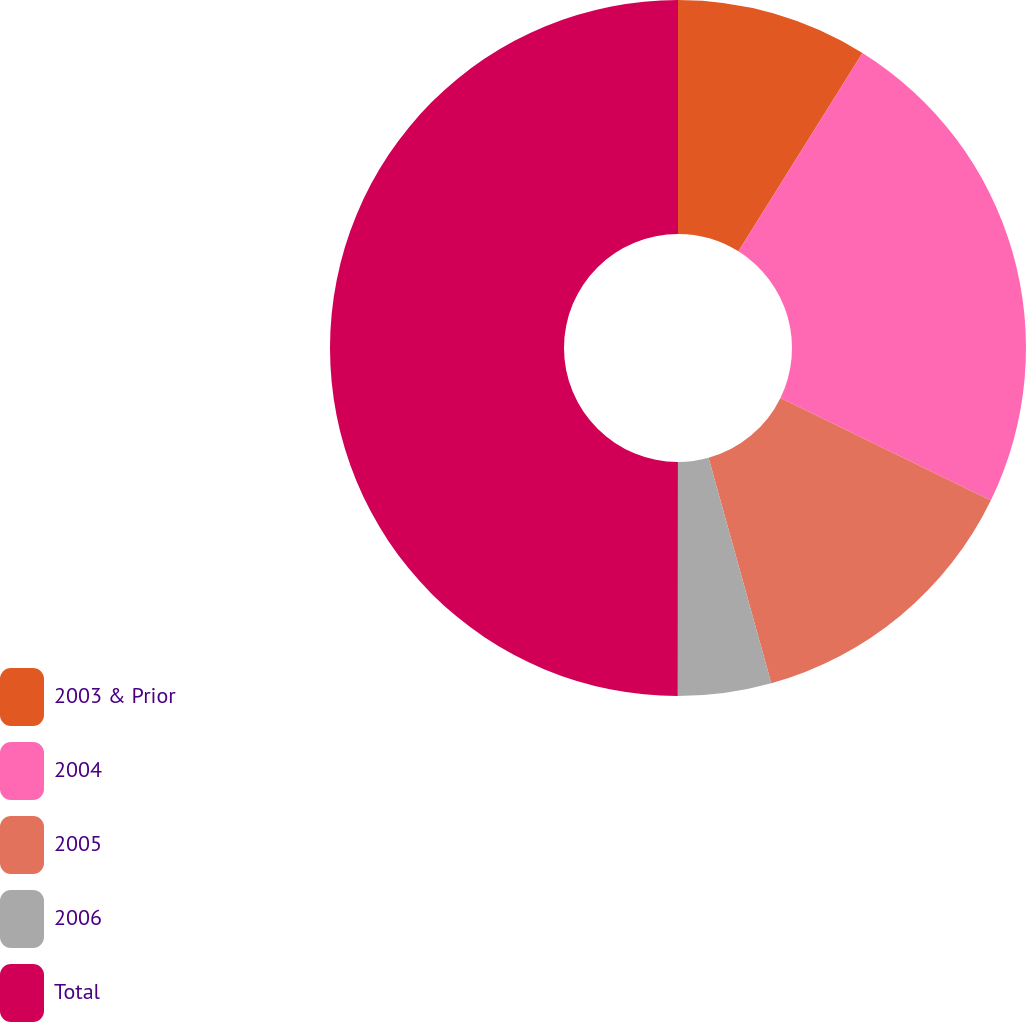Convert chart. <chart><loc_0><loc_0><loc_500><loc_500><pie_chart><fcel>2003 & Prior<fcel>2004<fcel>2005<fcel>2006<fcel>Total<nl><fcel>8.89%<fcel>23.33%<fcel>13.46%<fcel>4.33%<fcel>49.99%<nl></chart> 